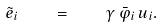<formula> <loc_0><loc_0><loc_500><loc_500>\tilde { e } _ { i } \quad = \quad \gamma \, \bar { \varphi } _ { i } \, u _ { i } .</formula> 